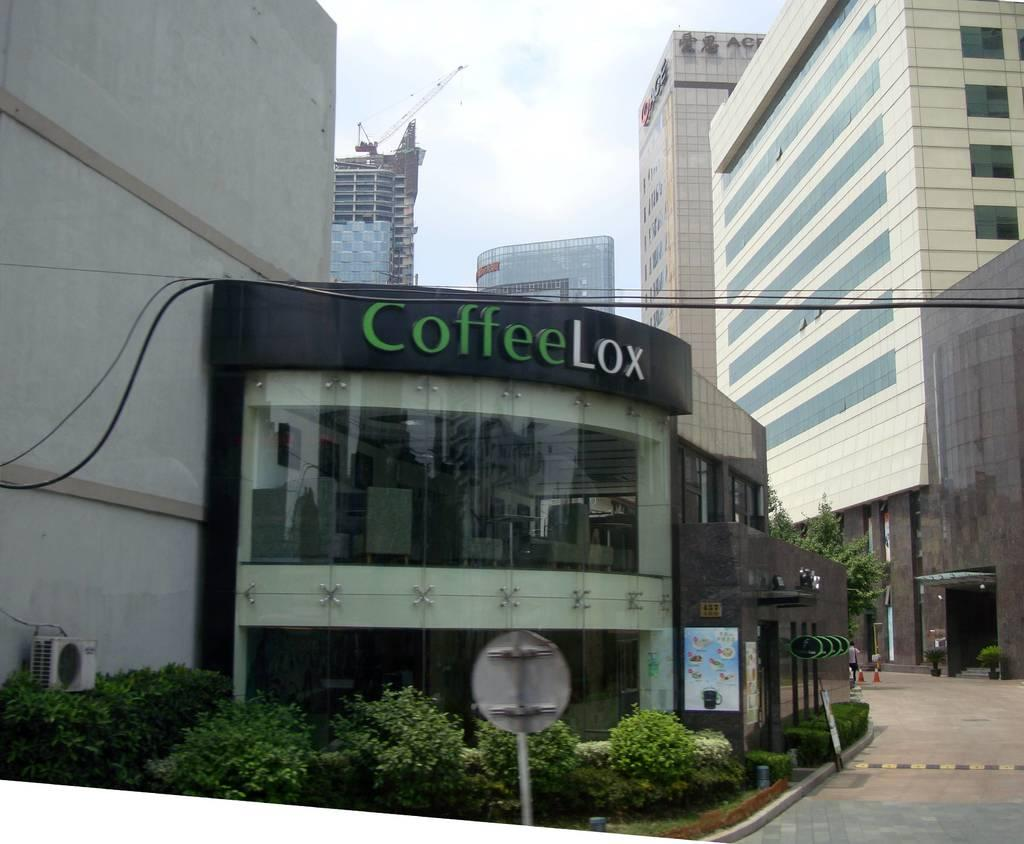What type of structure is the main subject of the image? There is a commercial building in the image. What can be seen in front of the commercial building? There are plants in front of the commercial building. What else is visible in the image besides the commercial building and plants? There are wires visible in the image. What can be seen in the background of the image? There are many tall buildings in the background of the image. What type of fuel is being used by the governor in the image? There is no governor present in the image, and therefore no fuel usage can be observed. What angle is the building leaning at in the image? The building is not leaning in the image; it is standing upright. 